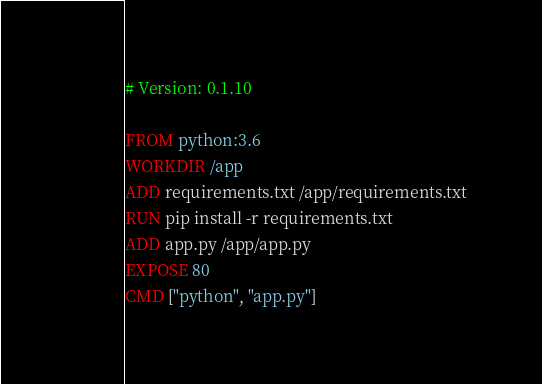Convert code to text. <code><loc_0><loc_0><loc_500><loc_500><_Dockerfile_># Version: 0.1.10

FROM python:3.6
WORKDIR /app
ADD requirements.txt /app/requirements.txt
RUN pip install -r requirements.txt
ADD app.py /app/app.py
EXPOSE 80
CMD ["python", "app.py"]
</code> 